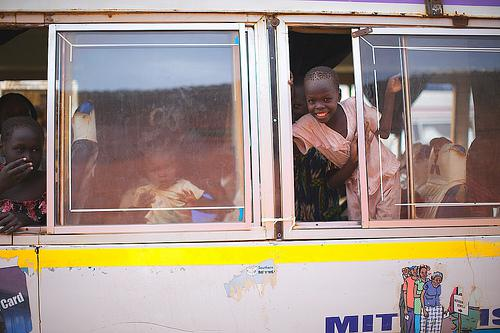Question: what is open?
Choices:
A. The door.
B. The fridge.
C. The stall.
D. The windows.
Answer with the letter. Answer: D Question: why is the one boy smiling?
Choices:
A. He's happy.
B. He's playing.
C. For the camera.
D. It's his birthday.
Answer with the letter. Answer: C Question: who is looking at the camera?
Choices:
A. A child.
B. A woman.
C. A man.
D. A kid.
Answer with the letter. Answer: A Question: what color is the bus?
Choices:
A. Yellow.
B. Blue.
C. Red.
D. White.
Answer with the letter. Answer: D Question: what words can be seen on the bus?
Choices:
A. Enter.
B. Exit.
C. MIT.
D. Emergency.
Answer with the letter. Answer: C 